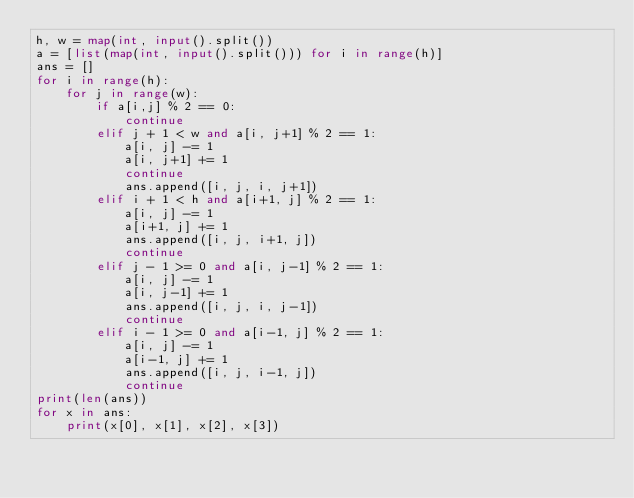<code> <loc_0><loc_0><loc_500><loc_500><_Python_>h, w = map(int, input().split())
a = [list(map(int, input().split())) for i in range(h)]
ans = []
for i in range(h):
    for j in range(w):
        if a[i,j] % 2 == 0:
            continue
        elif j + 1 < w and a[i, j+1] % 2 == 1:
            a[i, j] -= 1
            a[i, j+1] += 1
            continue
            ans.append([i, j, i, j+1])
        elif i + 1 < h and a[i+1, j] % 2 == 1:
            a[i, j] -= 1
            a[i+1, j] += 1
            ans.append([i, j, i+1, j])
            continue
        elif j - 1 >= 0 and a[i, j-1] % 2 == 1:
            a[i, j] -= 1
            a[i, j-1] += 1
            ans.append([i, j, i, j-1])
            continue
        elif i - 1 >= 0 and a[i-1, j] % 2 == 1:
            a[i, j] -= 1
            a[i-1, j] += 1
            ans.append([i, j, i-1, j])
            continue
print(len(ans))
for x in ans:
    print(x[0], x[1], x[2], x[3])
</code> 